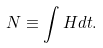<formula> <loc_0><loc_0><loc_500><loc_500>N \equiv \int { H d t } .</formula> 